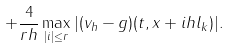<formula> <loc_0><loc_0><loc_500><loc_500>+ \frac { 4 } { r h } \max _ { | i | \leq r } | ( v _ { h } - g ) ( t , x + i h l _ { k } ) | .</formula> 